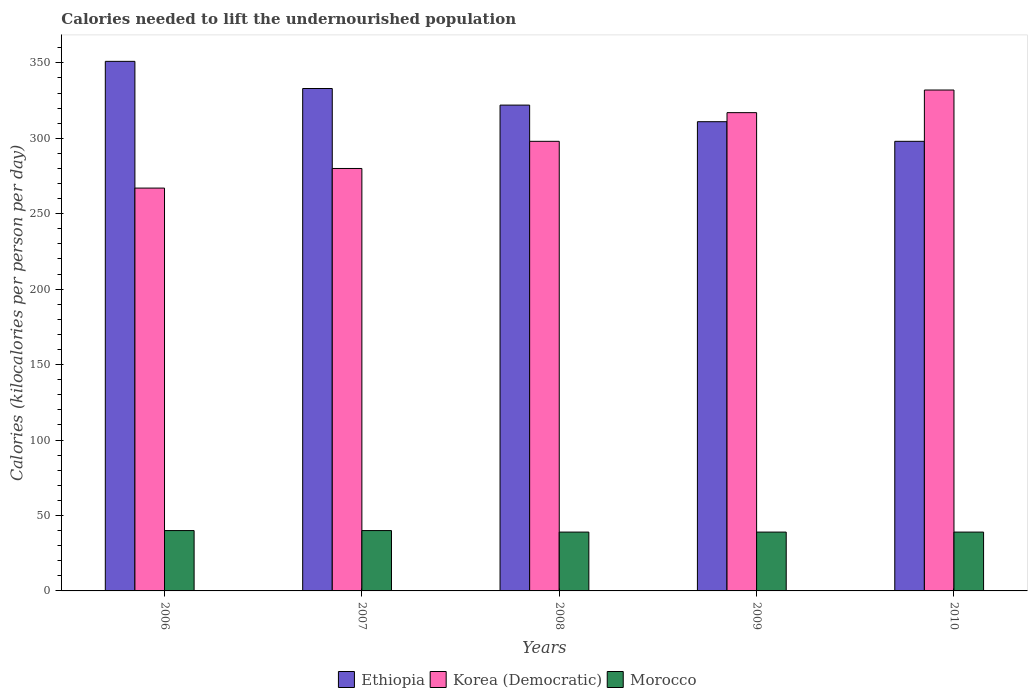How many bars are there on the 2nd tick from the left?
Offer a terse response. 3. How many bars are there on the 1st tick from the right?
Your response must be concise. 3. What is the total calories needed to lift the undernourished population in Korea (Democratic) in 2008?
Offer a terse response. 298. Across all years, what is the maximum total calories needed to lift the undernourished population in Korea (Democratic)?
Your answer should be very brief. 332. Across all years, what is the minimum total calories needed to lift the undernourished population in Korea (Democratic)?
Your response must be concise. 267. In which year was the total calories needed to lift the undernourished population in Morocco maximum?
Make the answer very short. 2006. In which year was the total calories needed to lift the undernourished population in Morocco minimum?
Your answer should be very brief. 2008. What is the total total calories needed to lift the undernourished population in Korea (Democratic) in the graph?
Ensure brevity in your answer.  1494. What is the difference between the total calories needed to lift the undernourished population in Ethiopia in 2009 and that in 2010?
Offer a very short reply. 13. What is the difference between the total calories needed to lift the undernourished population in Morocco in 2010 and the total calories needed to lift the undernourished population in Korea (Democratic) in 2006?
Make the answer very short. -228. What is the average total calories needed to lift the undernourished population in Korea (Democratic) per year?
Your answer should be compact. 298.8. In the year 2008, what is the difference between the total calories needed to lift the undernourished population in Korea (Democratic) and total calories needed to lift the undernourished population in Morocco?
Offer a terse response. 259. In how many years, is the total calories needed to lift the undernourished population in Korea (Democratic) greater than 310 kilocalories?
Your answer should be compact. 2. What is the ratio of the total calories needed to lift the undernourished population in Ethiopia in 2006 to that in 2008?
Give a very brief answer. 1.09. Is the total calories needed to lift the undernourished population in Morocco in 2008 less than that in 2010?
Offer a very short reply. No. Is the difference between the total calories needed to lift the undernourished population in Korea (Democratic) in 2008 and 2009 greater than the difference between the total calories needed to lift the undernourished population in Morocco in 2008 and 2009?
Provide a succinct answer. No. What is the difference between the highest and the lowest total calories needed to lift the undernourished population in Morocco?
Keep it short and to the point. 1. Is the sum of the total calories needed to lift the undernourished population in Morocco in 2007 and 2010 greater than the maximum total calories needed to lift the undernourished population in Korea (Democratic) across all years?
Your response must be concise. No. What does the 1st bar from the left in 2010 represents?
Provide a succinct answer. Ethiopia. What does the 1st bar from the right in 2009 represents?
Provide a succinct answer. Morocco. How many years are there in the graph?
Make the answer very short. 5. What is the difference between two consecutive major ticks on the Y-axis?
Your answer should be very brief. 50. Are the values on the major ticks of Y-axis written in scientific E-notation?
Offer a terse response. No. Does the graph contain grids?
Keep it short and to the point. No. How many legend labels are there?
Provide a short and direct response. 3. How are the legend labels stacked?
Offer a very short reply. Horizontal. What is the title of the graph?
Your answer should be very brief. Calories needed to lift the undernourished population. Does "Small states" appear as one of the legend labels in the graph?
Give a very brief answer. No. What is the label or title of the Y-axis?
Provide a short and direct response. Calories (kilocalories per person per day). What is the Calories (kilocalories per person per day) of Ethiopia in 2006?
Your answer should be very brief. 351. What is the Calories (kilocalories per person per day) in Korea (Democratic) in 2006?
Offer a very short reply. 267. What is the Calories (kilocalories per person per day) in Ethiopia in 2007?
Make the answer very short. 333. What is the Calories (kilocalories per person per day) in Korea (Democratic) in 2007?
Your response must be concise. 280. What is the Calories (kilocalories per person per day) in Morocco in 2007?
Your answer should be compact. 40. What is the Calories (kilocalories per person per day) in Ethiopia in 2008?
Your answer should be compact. 322. What is the Calories (kilocalories per person per day) of Korea (Democratic) in 2008?
Keep it short and to the point. 298. What is the Calories (kilocalories per person per day) of Morocco in 2008?
Offer a very short reply. 39. What is the Calories (kilocalories per person per day) of Ethiopia in 2009?
Your answer should be very brief. 311. What is the Calories (kilocalories per person per day) in Korea (Democratic) in 2009?
Offer a very short reply. 317. What is the Calories (kilocalories per person per day) in Ethiopia in 2010?
Give a very brief answer. 298. What is the Calories (kilocalories per person per day) in Korea (Democratic) in 2010?
Your answer should be compact. 332. What is the Calories (kilocalories per person per day) in Morocco in 2010?
Ensure brevity in your answer.  39. Across all years, what is the maximum Calories (kilocalories per person per day) in Ethiopia?
Give a very brief answer. 351. Across all years, what is the maximum Calories (kilocalories per person per day) in Korea (Democratic)?
Provide a short and direct response. 332. Across all years, what is the minimum Calories (kilocalories per person per day) of Ethiopia?
Offer a very short reply. 298. Across all years, what is the minimum Calories (kilocalories per person per day) of Korea (Democratic)?
Your answer should be very brief. 267. What is the total Calories (kilocalories per person per day) in Ethiopia in the graph?
Ensure brevity in your answer.  1615. What is the total Calories (kilocalories per person per day) of Korea (Democratic) in the graph?
Offer a very short reply. 1494. What is the total Calories (kilocalories per person per day) of Morocco in the graph?
Make the answer very short. 197. What is the difference between the Calories (kilocalories per person per day) in Korea (Democratic) in 2006 and that in 2007?
Your answer should be very brief. -13. What is the difference between the Calories (kilocalories per person per day) in Ethiopia in 2006 and that in 2008?
Ensure brevity in your answer.  29. What is the difference between the Calories (kilocalories per person per day) of Korea (Democratic) in 2006 and that in 2008?
Offer a very short reply. -31. What is the difference between the Calories (kilocalories per person per day) in Korea (Democratic) in 2006 and that in 2009?
Keep it short and to the point. -50. What is the difference between the Calories (kilocalories per person per day) of Morocco in 2006 and that in 2009?
Provide a short and direct response. 1. What is the difference between the Calories (kilocalories per person per day) in Ethiopia in 2006 and that in 2010?
Offer a very short reply. 53. What is the difference between the Calories (kilocalories per person per day) of Korea (Democratic) in 2006 and that in 2010?
Offer a very short reply. -65. What is the difference between the Calories (kilocalories per person per day) of Korea (Democratic) in 2007 and that in 2008?
Provide a short and direct response. -18. What is the difference between the Calories (kilocalories per person per day) of Ethiopia in 2007 and that in 2009?
Offer a terse response. 22. What is the difference between the Calories (kilocalories per person per day) in Korea (Democratic) in 2007 and that in 2009?
Your answer should be compact. -37. What is the difference between the Calories (kilocalories per person per day) in Korea (Democratic) in 2007 and that in 2010?
Ensure brevity in your answer.  -52. What is the difference between the Calories (kilocalories per person per day) in Morocco in 2007 and that in 2010?
Ensure brevity in your answer.  1. What is the difference between the Calories (kilocalories per person per day) of Ethiopia in 2008 and that in 2009?
Your response must be concise. 11. What is the difference between the Calories (kilocalories per person per day) of Morocco in 2008 and that in 2009?
Provide a succinct answer. 0. What is the difference between the Calories (kilocalories per person per day) of Ethiopia in 2008 and that in 2010?
Give a very brief answer. 24. What is the difference between the Calories (kilocalories per person per day) in Korea (Democratic) in 2008 and that in 2010?
Your answer should be very brief. -34. What is the difference between the Calories (kilocalories per person per day) of Morocco in 2008 and that in 2010?
Make the answer very short. 0. What is the difference between the Calories (kilocalories per person per day) of Ethiopia in 2009 and that in 2010?
Your answer should be compact. 13. What is the difference between the Calories (kilocalories per person per day) in Morocco in 2009 and that in 2010?
Keep it short and to the point. 0. What is the difference between the Calories (kilocalories per person per day) of Ethiopia in 2006 and the Calories (kilocalories per person per day) of Morocco in 2007?
Your answer should be very brief. 311. What is the difference between the Calories (kilocalories per person per day) of Korea (Democratic) in 2006 and the Calories (kilocalories per person per day) of Morocco in 2007?
Offer a very short reply. 227. What is the difference between the Calories (kilocalories per person per day) in Ethiopia in 2006 and the Calories (kilocalories per person per day) in Morocco in 2008?
Provide a short and direct response. 312. What is the difference between the Calories (kilocalories per person per day) in Korea (Democratic) in 2006 and the Calories (kilocalories per person per day) in Morocco in 2008?
Give a very brief answer. 228. What is the difference between the Calories (kilocalories per person per day) in Ethiopia in 2006 and the Calories (kilocalories per person per day) in Korea (Democratic) in 2009?
Your answer should be compact. 34. What is the difference between the Calories (kilocalories per person per day) of Ethiopia in 2006 and the Calories (kilocalories per person per day) of Morocco in 2009?
Your answer should be very brief. 312. What is the difference between the Calories (kilocalories per person per day) of Korea (Democratic) in 2006 and the Calories (kilocalories per person per day) of Morocco in 2009?
Provide a succinct answer. 228. What is the difference between the Calories (kilocalories per person per day) of Ethiopia in 2006 and the Calories (kilocalories per person per day) of Morocco in 2010?
Your response must be concise. 312. What is the difference between the Calories (kilocalories per person per day) in Korea (Democratic) in 2006 and the Calories (kilocalories per person per day) in Morocco in 2010?
Your answer should be compact. 228. What is the difference between the Calories (kilocalories per person per day) of Ethiopia in 2007 and the Calories (kilocalories per person per day) of Morocco in 2008?
Offer a very short reply. 294. What is the difference between the Calories (kilocalories per person per day) of Korea (Democratic) in 2007 and the Calories (kilocalories per person per day) of Morocco in 2008?
Give a very brief answer. 241. What is the difference between the Calories (kilocalories per person per day) in Ethiopia in 2007 and the Calories (kilocalories per person per day) in Morocco in 2009?
Offer a very short reply. 294. What is the difference between the Calories (kilocalories per person per day) of Korea (Democratic) in 2007 and the Calories (kilocalories per person per day) of Morocco in 2009?
Your answer should be very brief. 241. What is the difference between the Calories (kilocalories per person per day) in Ethiopia in 2007 and the Calories (kilocalories per person per day) in Morocco in 2010?
Give a very brief answer. 294. What is the difference between the Calories (kilocalories per person per day) in Korea (Democratic) in 2007 and the Calories (kilocalories per person per day) in Morocco in 2010?
Provide a short and direct response. 241. What is the difference between the Calories (kilocalories per person per day) in Ethiopia in 2008 and the Calories (kilocalories per person per day) in Korea (Democratic) in 2009?
Your answer should be very brief. 5. What is the difference between the Calories (kilocalories per person per day) in Ethiopia in 2008 and the Calories (kilocalories per person per day) in Morocco in 2009?
Give a very brief answer. 283. What is the difference between the Calories (kilocalories per person per day) in Korea (Democratic) in 2008 and the Calories (kilocalories per person per day) in Morocco in 2009?
Provide a succinct answer. 259. What is the difference between the Calories (kilocalories per person per day) of Ethiopia in 2008 and the Calories (kilocalories per person per day) of Morocco in 2010?
Give a very brief answer. 283. What is the difference between the Calories (kilocalories per person per day) in Korea (Democratic) in 2008 and the Calories (kilocalories per person per day) in Morocco in 2010?
Give a very brief answer. 259. What is the difference between the Calories (kilocalories per person per day) of Ethiopia in 2009 and the Calories (kilocalories per person per day) of Korea (Democratic) in 2010?
Your answer should be compact. -21. What is the difference between the Calories (kilocalories per person per day) in Ethiopia in 2009 and the Calories (kilocalories per person per day) in Morocco in 2010?
Provide a short and direct response. 272. What is the difference between the Calories (kilocalories per person per day) of Korea (Democratic) in 2009 and the Calories (kilocalories per person per day) of Morocco in 2010?
Provide a succinct answer. 278. What is the average Calories (kilocalories per person per day) in Ethiopia per year?
Provide a succinct answer. 323. What is the average Calories (kilocalories per person per day) of Korea (Democratic) per year?
Offer a terse response. 298.8. What is the average Calories (kilocalories per person per day) in Morocco per year?
Ensure brevity in your answer.  39.4. In the year 2006, what is the difference between the Calories (kilocalories per person per day) of Ethiopia and Calories (kilocalories per person per day) of Korea (Democratic)?
Offer a very short reply. 84. In the year 2006, what is the difference between the Calories (kilocalories per person per day) of Ethiopia and Calories (kilocalories per person per day) of Morocco?
Ensure brevity in your answer.  311. In the year 2006, what is the difference between the Calories (kilocalories per person per day) in Korea (Democratic) and Calories (kilocalories per person per day) in Morocco?
Your answer should be compact. 227. In the year 2007, what is the difference between the Calories (kilocalories per person per day) of Ethiopia and Calories (kilocalories per person per day) of Morocco?
Give a very brief answer. 293. In the year 2007, what is the difference between the Calories (kilocalories per person per day) in Korea (Democratic) and Calories (kilocalories per person per day) in Morocco?
Your answer should be compact. 240. In the year 2008, what is the difference between the Calories (kilocalories per person per day) of Ethiopia and Calories (kilocalories per person per day) of Korea (Democratic)?
Your answer should be compact. 24. In the year 2008, what is the difference between the Calories (kilocalories per person per day) in Ethiopia and Calories (kilocalories per person per day) in Morocco?
Offer a very short reply. 283. In the year 2008, what is the difference between the Calories (kilocalories per person per day) in Korea (Democratic) and Calories (kilocalories per person per day) in Morocco?
Your answer should be very brief. 259. In the year 2009, what is the difference between the Calories (kilocalories per person per day) of Ethiopia and Calories (kilocalories per person per day) of Morocco?
Make the answer very short. 272. In the year 2009, what is the difference between the Calories (kilocalories per person per day) of Korea (Democratic) and Calories (kilocalories per person per day) of Morocco?
Keep it short and to the point. 278. In the year 2010, what is the difference between the Calories (kilocalories per person per day) in Ethiopia and Calories (kilocalories per person per day) in Korea (Democratic)?
Keep it short and to the point. -34. In the year 2010, what is the difference between the Calories (kilocalories per person per day) in Ethiopia and Calories (kilocalories per person per day) in Morocco?
Your answer should be compact. 259. In the year 2010, what is the difference between the Calories (kilocalories per person per day) in Korea (Democratic) and Calories (kilocalories per person per day) in Morocco?
Offer a terse response. 293. What is the ratio of the Calories (kilocalories per person per day) of Ethiopia in 2006 to that in 2007?
Your answer should be compact. 1.05. What is the ratio of the Calories (kilocalories per person per day) in Korea (Democratic) in 2006 to that in 2007?
Offer a very short reply. 0.95. What is the ratio of the Calories (kilocalories per person per day) in Ethiopia in 2006 to that in 2008?
Offer a terse response. 1.09. What is the ratio of the Calories (kilocalories per person per day) of Korea (Democratic) in 2006 to that in 2008?
Offer a very short reply. 0.9. What is the ratio of the Calories (kilocalories per person per day) in Morocco in 2006 to that in 2008?
Give a very brief answer. 1.03. What is the ratio of the Calories (kilocalories per person per day) of Ethiopia in 2006 to that in 2009?
Your answer should be very brief. 1.13. What is the ratio of the Calories (kilocalories per person per day) of Korea (Democratic) in 2006 to that in 2009?
Ensure brevity in your answer.  0.84. What is the ratio of the Calories (kilocalories per person per day) of Morocco in 2006 to that in 2009?
Your response must be concise. 1.03. What is the ratio of the Calories (kilocalories per person per day) of Ethiopia in 2006 to that in 2010?
Offer a terse response. 1.18. What is the ratio of the Calories (kilocalories per person per day) of Korea (Democratic) in 2006 to that in 2010?
Ensure brevity in your answer.  0.8. What is the ratio of the Calories (kilocalories per person per day) in Morocco in 2006 to that in 2010?
Ensure brevity in your answer.  1.03. What is the ratio of the Calories (kilocalories per person per day) of Ethiopia in 2007 to that in 2008?
Your answer should be compact. 1.03. What is the ratio of the Calories (kilocalories per person per day) of Korea (Democratic) in 2007 to that in 2008?
Provide a short and direct response. 0.94. What is the ratio of the Calories (kilocalories per person per day) in Morocco in 2007 to that in 2008?
Your answer should be very brief. 1.03. What is the ratio of the Calories (kilocalories per person per day) of Ethiopia in 2007 to that in 2009?
Provide a short and direct response. 1.07. What is the ratio of the Calories (kilocalories per person per day) in Korea (Democratic) in 2007 to that in 2009?
Offer a terse response. 0.88. What is the ratio of the Calories (kilocalories per person per day) in Morocco in 2007 to that in 2009?
Your response must be concise. 1.03. What is the ratio of the Calories (kilocalories per person per day) of Ethiopia in 2007 to that in 2010?
Give a very brief answer. 1.12. What is the ratio of the Calories (kilocalories per person per day) of Korea (Democratic) in 2007 to that in 2010?
Provide a succinct answer. 0.84. What is the ratio of the Calories (kilocalories per person per day) in Morocco in 2007 to that in 2010?
Your answer should be very brief. 1.03. What is the ratio of the Calories (kilocalories per person per day) in Ethiopia in 2008 to that in 2009?
Provide a succinct answer. 1.04. What is the ratio of the Calories (kilocalories per person per day) of Korea (Democratic) in 2008 to that in 2009?
Offer a terse response. 0.94. What is the ratio of the Calories (kilocalories per person per day) in Ethiopia in 2008 to that in 2010?
Your response must be concise. 1.08. What is the ratio of the Calories (kilocalories per person per day) of Korea (Democratic) in 2008 to that in 2010?
Offer a terse response. 0.9. What is the ratio of the Calories (kilocalories per person per day) of Morocco in 2008 to that in 2010?
Give a very brief answer. 1. What is the ratio of the Calories (kilocalories per person per day) in Ethiopia in 2009 to that in 2010?
Your answer should be compact. 1.04. What is the ratio of the Calories (kilocalories per person per day) in Korea (Democratic) in 2009 to that in 2010?
Your response must be concise. 0.95. What is the difference between the highest and the second highest Calories (kilocalories per person per day) in Ethiopia?
Ensure brevity in your answer.  18. What is the difference between the highest and the lowest Calories (kilocalories per person per day) of Morocco?
Offer a very short reply. 1. 